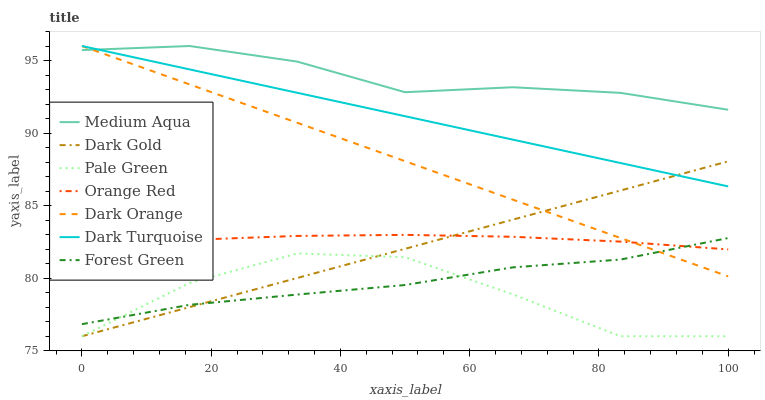Does Pale Green have the minimum area under the curve?
Answer yes or no. Yes. Does Medium Aqua have the maximum area under the curve?
Answer yes or no. Yes. Does Dark Gold have the minimum area under the curve?
Answer yes or no. No. Does Dark Gold have the maximum area under the curve?
Answer yes or no. No. Is Dark Orange the smoothest?
Answer yes or no. Yes. Is Pale Green the roughest?
Answer yes or no. Yes. Is Dark Gold the smoothest?
Answer yes or no. No. Is Dark Gold the roughest?
Answer yes or no. No. Does Dark Gold have the lowest value?
Answer yes or no. Yes. Does Dark Turquoise have the lowest value?
Answer yes or no. No. Does Medium Aqua have the highest value?
Answer yes or no. Yes. Does Dark Gold have the highest value?
Answer yes or no. No. Is Dark Gold less than Medium Aqua?
Answer yes or no. Yes. Is Medium Aqua greater than Pale Green?
Answer yes or no. Yes. Does Dark Turquoise intersect Dark Gold?
Answer yes or no. Yes. Is Dark Turquoise less than Dark Gold?
Answer yes or no. No. Is Dark Turquoise greater than Dark Gold?
Answer yes or no. No. Does Dark Gold intersect Medium Aqua?
Answer yes or no. No. 